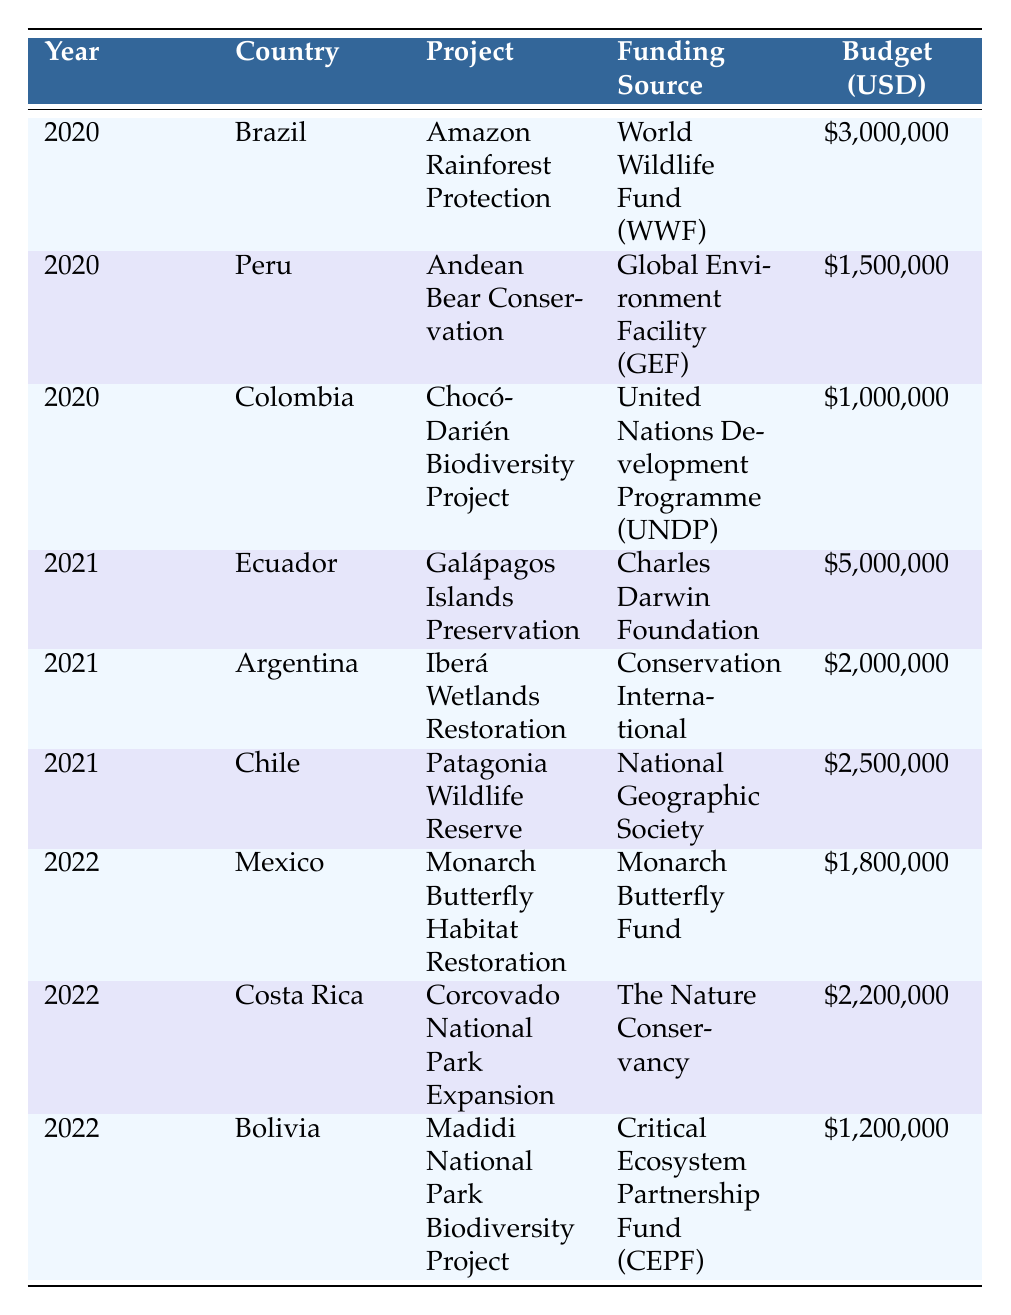What is the total funding allocated for biodiversity conservation projects in Brazil during the years 2020 to 2022? Looking at the table, Brazil only has one entry in the year 2020, which is for the Amazon Rainforest Protection project. The budget for this project is 3,000,000 USD. Therefore, the total funding allocated for Brazil from 2020 to 2022 is 3,000,000 USD.
Answer: 3,000,000 USD Which funding source provided the highest budget for a biodiversity project in 2021? In 2021, there are three projects listed with their respective budgets: Galápagos Islands Preservation (5,000,000 USD from Charles Darwin Foundation), Iberá Wetlands Restoration (2,000,000 USD from Conservation International), and Patagonia Wildlife Reserve (2,500,000 USD from National Geographic Society). The highest budget is 5,000,000 USD for the Galápagos Islands Preservation project.
Answer: Charles Darwin Foundation Is the funding allocated for the Monarch Butterfly Habitat Restoration project greater than the average funding for the projects in 2022? For 2022, the budgets for the three projects are: Monarch Butterfly Habitat Restoration (1,800,000 USD), Corcovado National Park Expansion (2,200,000 USD), and Madidi National Park Biodiversity Project (1,200,000 USD). The average funding is calculated by adding the budgets (1,800,000 + 2,200,000 + 1,200,000 = 5,200,000 USD) and then dividing by the number of projects (5,200,000 / 3 = 1,733,333.33 USD). Since 1,800,000 is greater than 1,733,333.33, the answer is yes.
Answer: Yes 